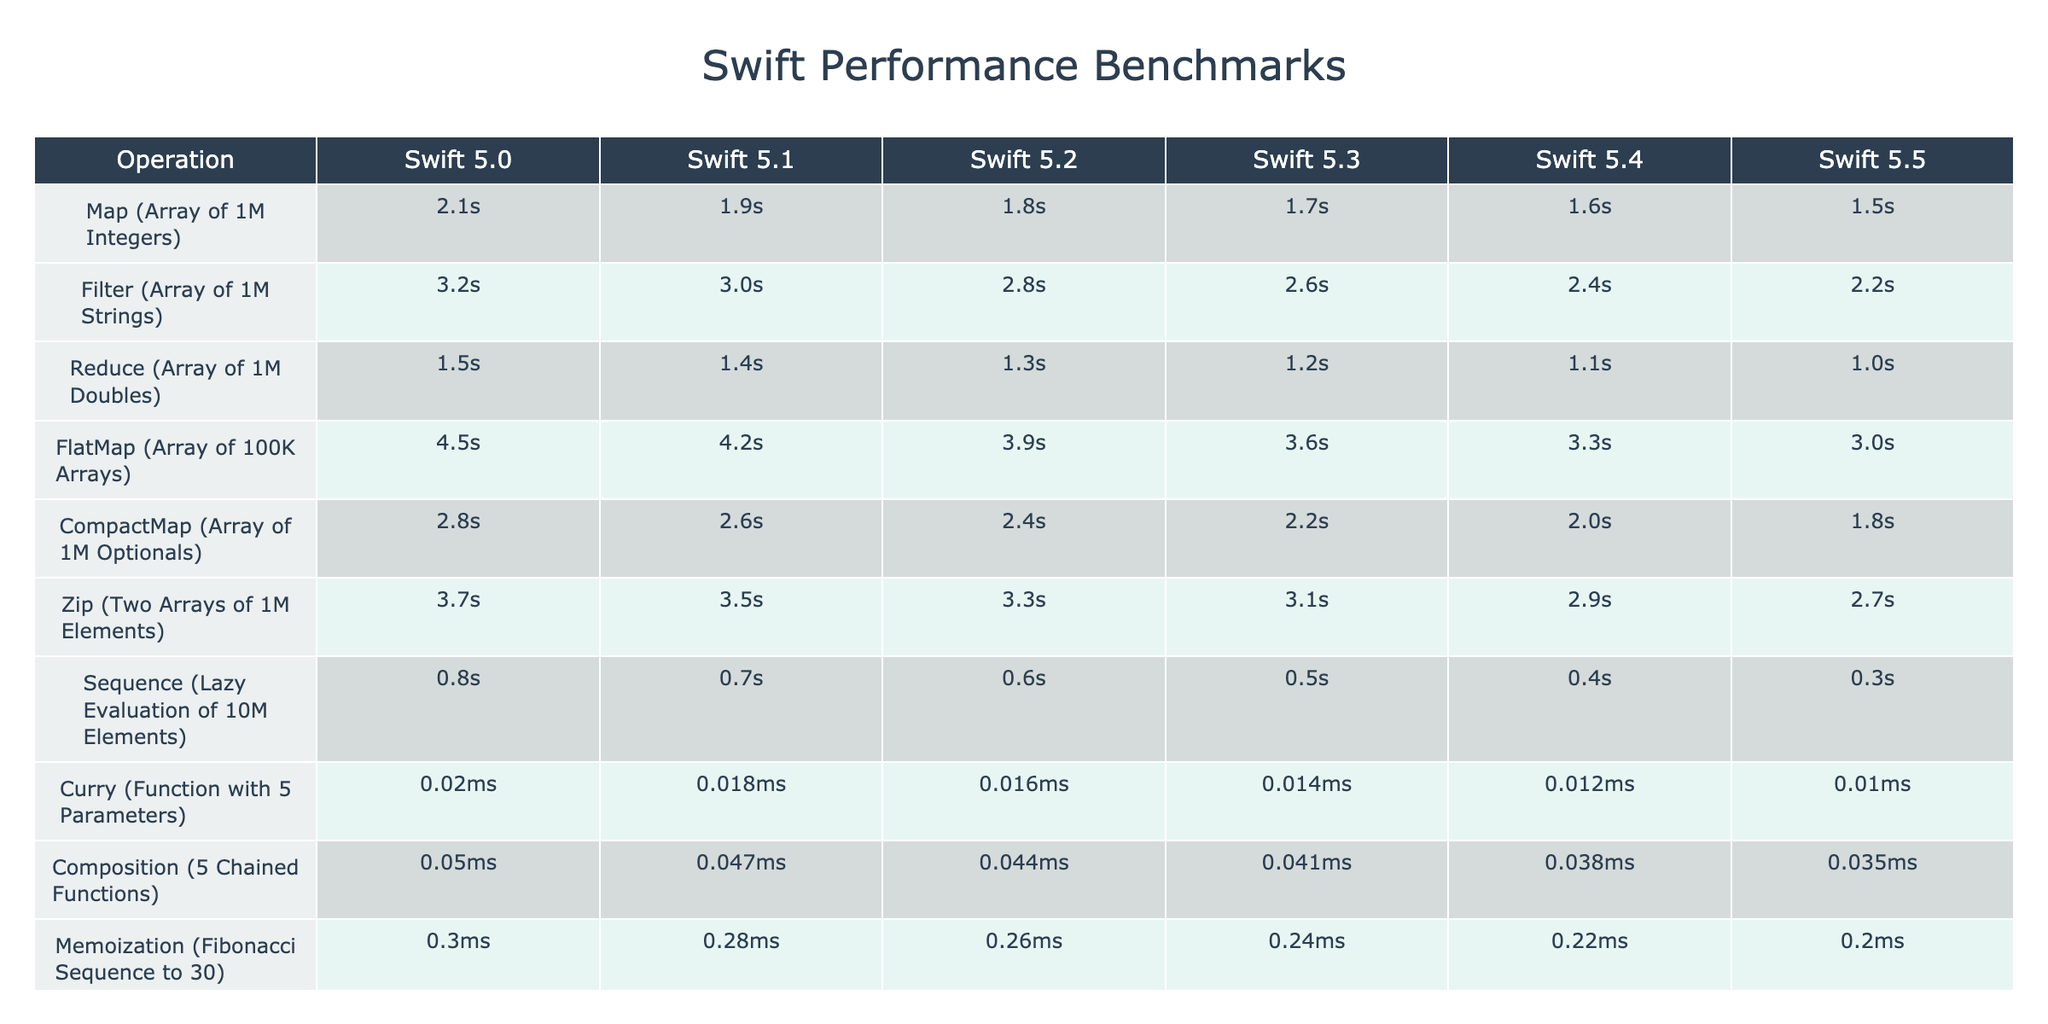What is the fastest operation in Swift 5.5? The fastest operation in Swift 5.5 is "Curry (Function with 5 Parameters)" with a time of 0.01ms. This can be found by looking at the last column for Swift 5.5 and identifying the minimum value among all operations.
Answer: 0.01ms In which Swift version did the "Map (Array of 1M Integers)" operation see its best performance? The "Map (Array of 1M Integers)" operation had its best performance in Swift 5.5, where it took 1.5s. This is determined by comparing the times for this operation across all versions in the corresponding row.
Answer: Swift 5.5 What is the average time taken for the "Filter" operation across all Swift versions? The times for the "Filter" operation are 3.2s, 3.0s, 2.8s, 2.6s, 2.4s, and 2.2s. Adding these up gives 3.2 + 3.0 + 2.8 + 2.6 + 2.4 + 2.2 = 16.2s. To find the average, divide by 6 (the number of versions): 16.2s / 6 = 2.7s.
Answer: 2.7s Has the performance of "Reduce (Array of 1M Doubles)" improved from Swift 5.0 to Swift 5.5? Yes, the performance of "Reduce (Array of 1M Doubles)" has improved from 1.5s in Swift 5.0 to 1.0s in Swift 5.5. This comparison is made by checking the values in the corresponding row for each Swift version.
Answer: Yes What is the percentage improvement in performance for "CompactMap (Array of 1M Optionals)" from Swift 5.0 to Swift 5.5? The performance for "CompactMap (Array of 1M Optionals)" improved from 2.8s to 1.8s. To calculate the percentage improvement, subtract the new value from the old one: 2.8s - 1.8s = 1.0s. Then divide the difference by the old value: (1.0s / 2.8s) * 100 = approximately 35.71%.
Answer: 35.71% Which operation shows the least performance improvement between Swift versions 5.0 and 5.5? The operation with the least performance improvement is "Curry (Function with 5 Parameters)" which decreased from 0.02ms to 0.01ms. The performance dropped by 0.01ms, which is the smallest change compared to other operations.
Answer: "Curry (Function with 5 Parameters)" 